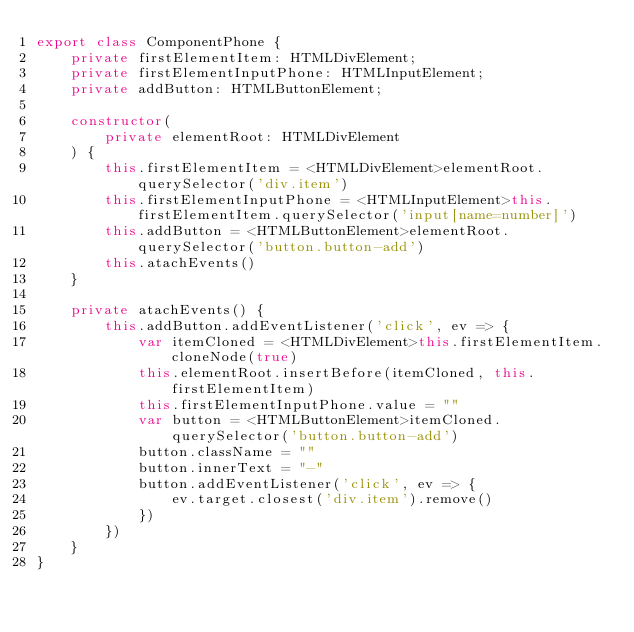<code> <loc_0><loc_0><loc_500><loc_500><_TypeScript_>export class ComponentPhone {
    private firstElementItem: HTMLDivElement;
    private firstElementInputPhone: HTMLInputElement;
    private addButton: HTMLButtonElement;

    constructor(
        private elementRoot: HTMLDivElement
    ) {
        this.firstElementItem = <HTMLDivElement>elementRoot.querySelector('div.item')
        this.firstElementInputPhone = <HTMLInputElement>this.firstElementItem.querySelector('input[name=number]')
        this.addButton = <HTMLButtonElement>elementRoot.querySelector('button.button-add')
        this.atachEvents()
    }

    private atachEvents() {
        this.addButton.addEventListener('click', ev => {
            var itemCloned = <HTMLDivElement>this.firstElementItem.cloneNode(true)
            this.elementRoot.insertBefore(itemCloned, this.firstElementItem)
            this.firstElementInputPhone.value = ""
            var button = <HTMLButtonElement>itemCloned.querySelector('button.button-add')
            button.className = ""
            button.innerText = "-"
            button.addEventListener('click', ev => {
                ev.target.closest('div.item').remove()
            })
        })
    }
}</code> 